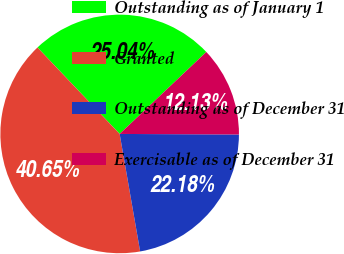Convert chart. <chart><loc_0><loc_0><loc_500><loc_500><pie_chart><fcel>Outstanding as of January 1<fcel>Granted<fcel>Outstanding as of December 31<fcel>Exercisable as of December 31<nl><fcel>25.04%<fcel>40.65%<fcel>22.18%<fcel>12.13%<nl></chart> 